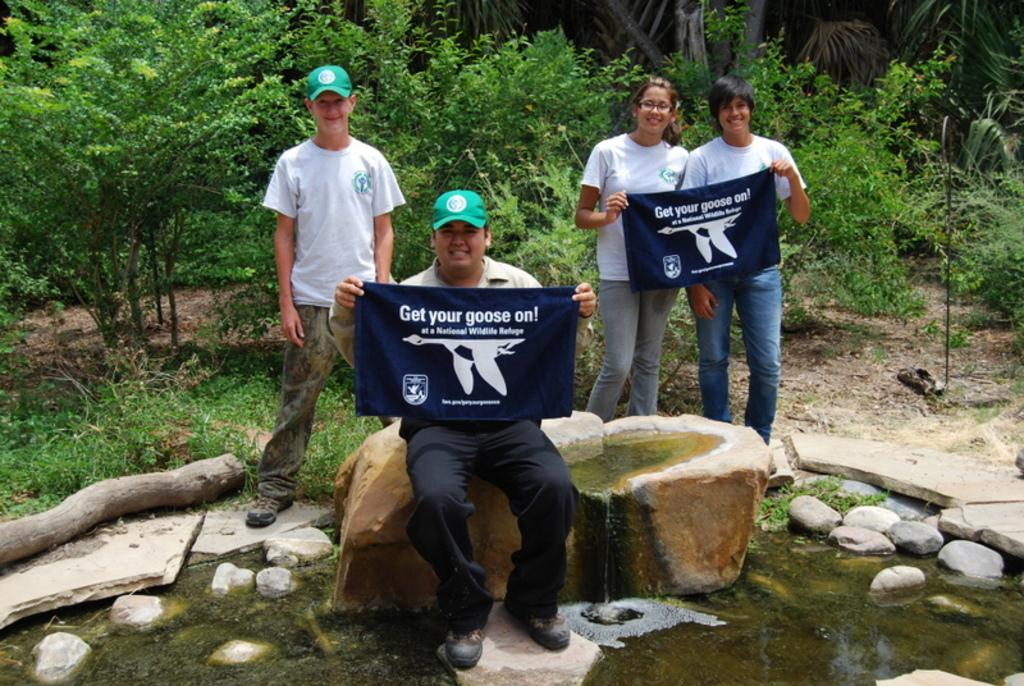Provide a one-sentence caption for the provided image. people holding banners that say 'get your goose on'. 